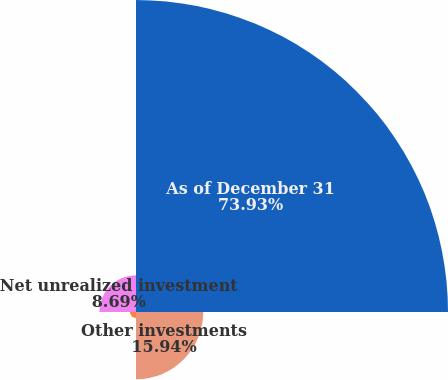Convert chart. <chart><loc_0><loc_0><loc_500><loc_500><pie_chart><fcel>As of December 31<fcel>Other investments<fcel>Deferred taxes<fcel>Net unrealized investment<nl><fcel>73.94%<fcel>15.94%<fcel>1.44%<fcel>8.69%<nl></chart> 